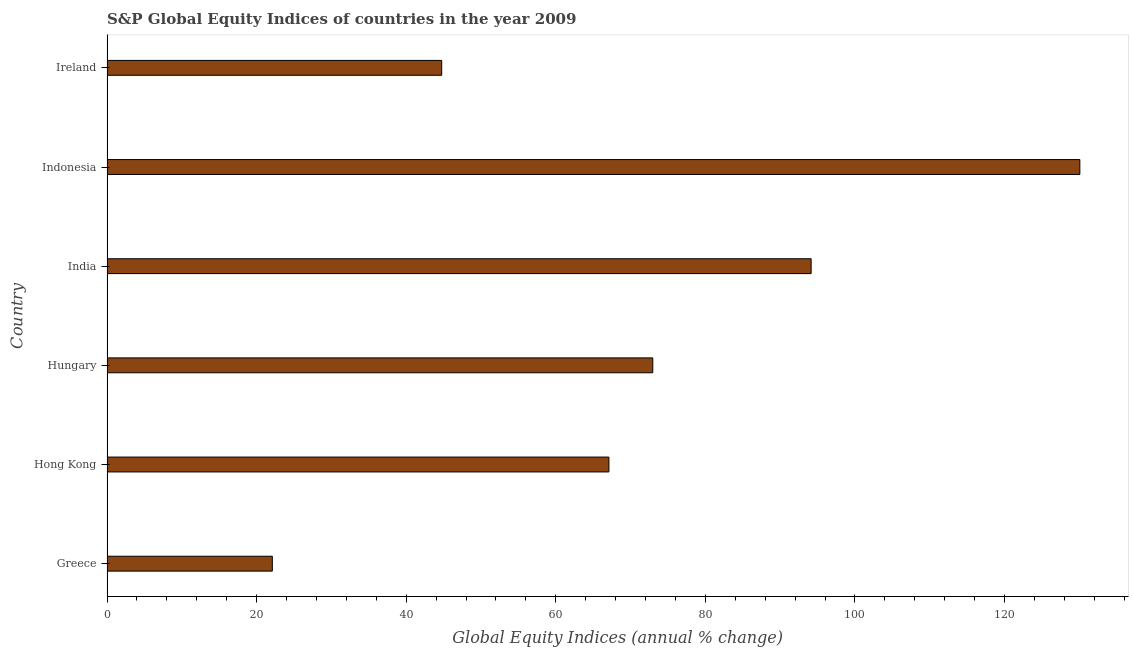What is the title of the graph?
Offer a very short reply. S&P Global Equity Indices of countries in the year 2009. What is the label or title of the X-axis?
Your answer should be compact. Global Equity Indices (annual % change). What is the s&p global equity indices in Hungary?
Offer a terse response. 72.97. Across all countries, what is the maximum s&p global equity indices?
Ensure brevity in your answer.  130.07. Across all countries, what is the minimum s&p global equity indices?
Offer a very short reply. 22.1. What is the sum of the s&p global equity indices?
Ensure brevity in your answer.  431.13. What is the difference between the s&p global equity indices in Hong Kong and Hungary?
Provide a short and direct response. -5.87. What is the average s&p global equity indices per country?
Your response must be concise. 71.86. What is the median s&p global equity indices?
Make the answer very short. 70.04. In how many countries, is the s&p global equity indices greater than 48 %?
Your response must be concise. 4. What is the ratio of the s&p global equity indices in Hong Kong to that in India?
Your answer should be compact. 0.71. What is the difference between the highest and the second highest s&p global equity indices?
Provide a succinct answer. 35.93. Is the sum of the s&p global equity indices in India and Indonesia greater than the maximum s&p global equity indices across all countries?
Give a very brief answer. Yes. What is the difference between the highest and the lowest s&p global equity indices?
Provide a succinct answer. 107.96. In how many countries, is the s&p global equity indices greater than the average s&p global equity indices taken over all countries?
Give a very brief answer. 3. How many bars are there?
Ensure brevity in your answer.  6. How many countries are there in the graph?
Your response must be concise. 6. What is the difference between two consecutive major ticks on the X-axis?
Provide a short and direct response. 20. What is the Global Equity Indices (annual % change) in Greece?
Provide a short and direct response. 22.1. What is the Global Equity Indices (annual % change) in Hong Kong?
Offer a terse response. 67.1. What is the Global Equity Indices (annual % change) in Hungary?
Provide a succinct answer. 72.97. What is the Global Equity Indices (annual % change) of India?
Provide a succinct answer. 94.14. What is the Global Equity Indices (annual % change) of Indonesia?
Make the answer very short. 130.07. What is the Global Equity Indices (annual % change) in Ireland?
Keep it short and to the point. 44.75. What is the difference between the Global Equity Indices (annual % change) in Greece and Hong Kong?
Ensure brevity in your answer.  -45. What is the difference between the Global Equity Indices (annual % change) in Greece and Hungary?
Your answer should be compact. -50.86. What is the difference between the Global Equity Indices (annual % change) in Greece and India?
Provide a succinct answer. -72.04. What is the difference between the Global Equity Indices (annual % change) in Greece and Indonesia?
Give a very brief answer. -107.96. What is the difference between the Global Equity Indices (annual % change) in Greece and Ireland?
Provide a succinct answer. -22.64. What is the difference between the Global Equity Indices (annual % change) in Hong Kong and Hungary?
Provide a short and direct response. -5.87. What is the difference between the Global Equity Indices (annual % change) in Hong Kong and India?
Your answer should be very brief. -27.04. What is the difference between the Global Equity Indices (annual % change) in Hong Kong and Indonesia?
Provide a succinct answer. -62.96. What is the difference between the Global Equity Indices (annual % change) in Hong Kong and Ireland?
Provide a short and direct response. 22.36. What is the difference between the Global Equity Indices (annual % change) in Hungary and India?
Ensure brevity in your answer.  -21.17. What is the difference between the Global Equity Indices (annual % change) in Hungary and Indonesia?
Offer a terse response. -57.1. What is the difference between the Global Equity Indices (annual % change) in Hungary and Ireland?
Provide a short and direct response. 28.22. What is the difference between the Global Equity Indices (annual % change) in India and Indonesia?
Provide a succinct answer. -35.93. What is the difference between the Global Equity Indices (annual % change) in India and Ireland?
Give a very brief answer. 49.39. What is the difference between the Global Equity Indices (annual % change) in Indonesia and Ireland?
Your answer should be very brief. 85.32. What is the ratio of the Global Equity Indices (annual % change) in Greece to that in Hong Kong?
Provide a succinct answer. 0.33. What is the ratio of the Global Equity Indices (annual % change) in Greece to that in Hungary?
Keep it short and to the point. 0.3. What is the ratio of the Global Equity Indices (annual % change) in Greece to that in India?
Your answer should be compact. 0.23. What is the ratio of the Global Equity Indices (annual % change) in Greece to that in Indonesia?
Give a very brief answer. 0.17. What is the ratio of the Global Equity Indices (annual % change) in Greece to that in Ireland?
Give a very brief answer. 0.49. What is the ratio of the Global Equity Indices (annual % change) in Hong Kong to that in Hungary?
Your response must be concise. 0.92. What is the ratio of the Global Equity Indices (annual % change) in Hong Kong to that in India?
Provide a succinct answer. 0.71. What is the ratio of the Global Equity Indices (annual % change) in Hong Kong to that in Indonesia?
Ensure brevity in your answer.  0.52. What is the ratio of the Global Equity Indices (annual % change) in Hungary to that in India?
Your answer should be compact. 0.78. What is the ratio of the Global Equity Indices (annual % change) in Hungary to that in Indonesia?
Offer a very short reply. 0.56. What is the ratio of the Global Equity Indices (annual % change) in Hungary to that in Ireland?
Make the answer very short. 1.63. What is the ratio of the Global Equity Indices (annual % change) in India to that in Indonesia?
Provide a succinct answer. 0.72. What is the ratio of the Global Equity Indices (annual % change) in India to that in Ireland?
Offer a very short reply. 2.1. What is the ratio of the Global Equity Indices (annual % change) in Indonesia to that in Ireland?
Your answer should be compact. 2.91. 